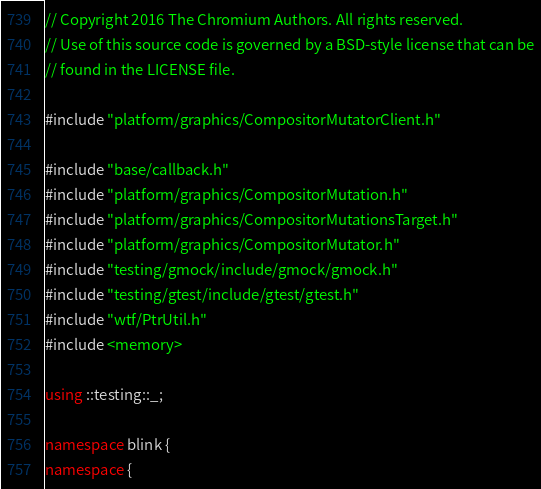<code> <loc_0><loc_0><loc_500><loc_500><_C++_>// Copyright 2016 The Chromium Authors. All rights reserved.
// Use of this source code is governed by a BSD-style license that can be
// found in the LICENSE file.

#include "platform/graphics/CompositorMutatorClient.h"

#include "base/callback.h"
#include "platform/graphics/CompositorMutation.h"
#include "platform/graphics/CompositorMutationsTarget.h"
#include "platform/graphics/CompositorMutator.h"
#include "testing/gmock/include/gmock/gmock.h"
#include "testing/gtest/include/gtest/gtest.h"
#include "wtf/PtrUtil.h"
#include <memory>

using ::testing::_;

namespace blink {
namespace {
</code> 